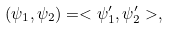<formula> <loc_0><loc_0><loc_500><loc_500>( \psi _ { 1 } , \psi _ { 2 } ) = < \psi ^ { \prime } _ { 1 } , \psi ^ { \prime } _ { 2 } > ,</formula> 